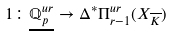Convert formula to latex. <formula><loc_0><loc_0><loc_500><loc_500>1 \colon \underline { \mathbb { Q } ^ { u r } _ { p } } \to \Delta ^ { * } \Pi _ { r - 1 } ^ { u r } ( X _ { \overline { K } } )</formula> 